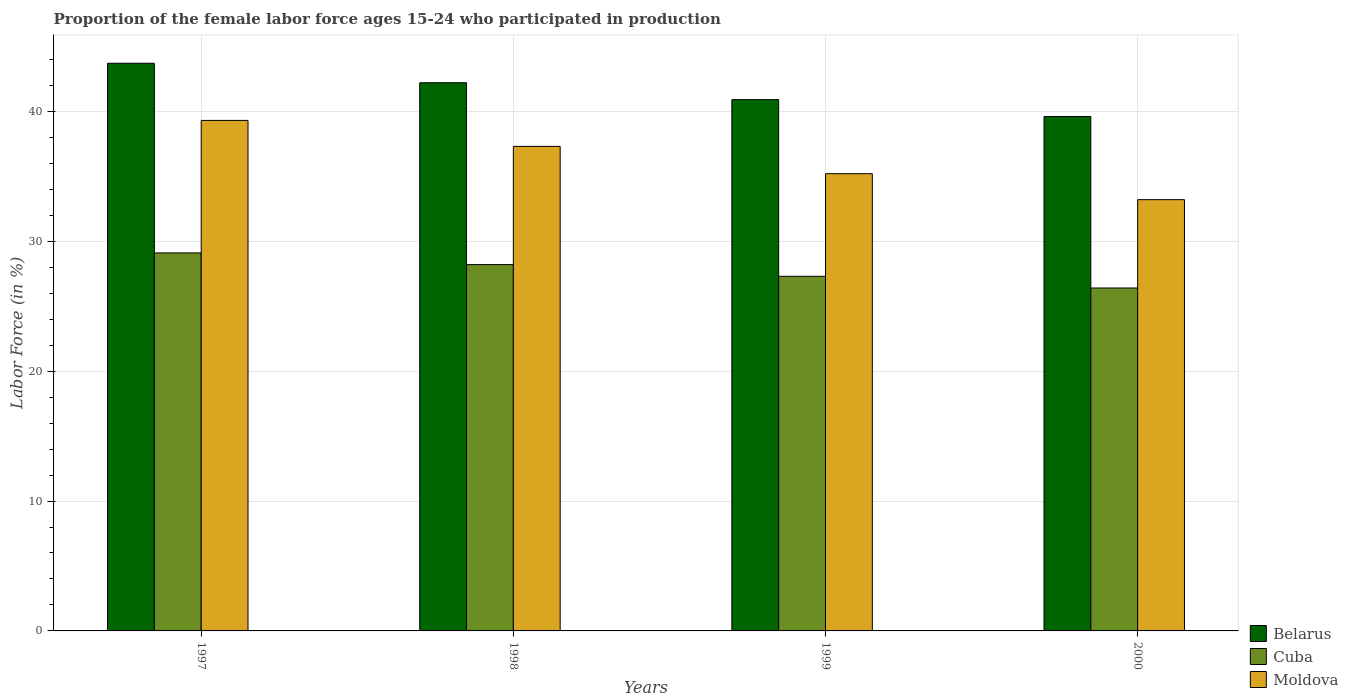How many groups of bars are there?
Provide a succinct answer. 4. What is the proportion of the female labor force who participated in production in Moldova in 1997?
Offer a very short reply. 39.3. Across all years, what is the maximum proportion of the female labor force who participated in production in Cuba?
Your answer should be compact. 29.1. Across all years, what is the minimum proportion of the female labor force who participated in production in Cuba?
Offer a terse response. 26.4. In which year was the proportion of the female labor force who participated in production in Belarus maximum?
Offer a terse response. 1997. In which year was the proportion of the female labor force who participated in production in Moldova minimum?
Keep it short and to the point. 2000. What is the total proportion of the female labor force who participated in production in Cuba in the graph?
Keep it short and to the point. 111. What is the difference between the proportion of the female labor force who participated in production in Cuba in 1999 and that in 2000?
Your answer should be compact. 0.9. What is the difference between the proportion of the female labor force who participated in production in Belarus in 1998 and the proportion of the female labor force who participated in production in Cuba in 1999?
Make the answer very short. 14.9. What is the average proportion of the female labor force who participated in production in Belarus per year?
Provide a short and direct response. 41.6. In the year 1997, what is the difference between the proportion of the female labor force who participated in production in Moldova and proportion of the female labor force who participated in production in Cuba?
Provide a succinct answer. 10.2. What is the ratio of the proportion of the female labor force who participated in production in Belarus in 1997 to that in 2000?
Keep it short and to the point. 1.1. Is the proportion of the female labor force who participated in production in Moldova in 1999 less than that in 2000?
Give a very brief answer. No. Is the difference between the proportion of the female labor force who participated in production in Moldova in 1999 and 2000 greater than the difference between the proportion of the female labor force who participated in production in Cuba in 1999 and 2000?
Give a very brief answer. Yes. What is the difference between the highest and the second highest proportion of the female labor force who participated in production in Belarus?
Ensure brevity in your answer.  1.5. What is the difference between the highest and the lowest proportion of the female labor force who participated in production in Cuba?
Offer a terse response. 2.7. In how many years, is the proportion of the female labor force who participated in production in Cuba greater than the average proportion of the female labor force who participated in production in Cuba taken over all years?
Your answer should be compact. 2. What does the 1st bar from the left in 1999 represents?
Your response must be concise. Belarus. What does the 3rd bar from the right in 1998 represents?
Ensure brevity in your answer.  Belarus. How many bars are there?
Offer a terse response. 12. Are all the bars in the graph horizontal?
Offer a terse response. No. Are the values on the major ticks of Y-axis written in scientific E-notation?
Give a very brief answer. No. Where does the legend appear in the graph?
Make the answer very short. Bottom right. How many legend labels are there?
Keep it short and to the point. 3. What is the title of the graph?
Your answer should be compact. Proportion of the female labor force ages 15-24 who participated in production. What is the label or title of the X-axis?
Ensure brevity in your answer.  Years. What is the label or title of the Y-axis?
Provide a short and direct response. Labor Force (in %). What is the Labor Force (in %) in Belarus in 1997?
Provide a short and direct response. 43.7. What is the Labor Force (in %) of Cuba in 1997?
Offer a very short reply. 29.1. What is the Labor Force (in %) in Moldova in 1997?
Provide a succinct answer. 39.3. What is the Labor Force (in %) of Belarus in 1998?
Make the answer very short. 42.2. What is the Labor Force (in %) in Cuba in 1998?
Your answer should be very brief. 28.2. What is the Labor Force (in %) of Moldova in 1998?
Give a very brief answer. 37.3. What is the Labor Force (in %) of Belarus in 1999?
Offer a terse response. 40.9. What is the Labor Force (in %) in Cuba in 1999?
Ensure brevity in your answer.  27.3. What is the Labor Force (in %) in Moldova in 1999?
Offer a very short reply. 35.2. What is the Labor Force (in %) in Belarus in 2000?
Keep it short and to the point. 39.6. What is the Labor Force (in %) in Cuba in 2000?
Ensure brevity in your answer.  26.4. What is the Labor Force (in %) in Moldova in 2000?
Keep it short and to the point. 33.2. Across all years, what is the maximum Labor Force (in %) of Belarus?
Your answer should be very brief. 43.7. Across all years, what is the maximum Labor Force (in %) of Cuba?
Keep it short and to the point. 29.1. Across all years, what is the maximum Labor Force (in %) of Moldova?
Provide a short and direct response. 39.3. Across all years, what is the minimum Labor Force (in %) of Belarus?
Make the answer very short. 39.6. Across all years, what is the minimum Labor Force (in %) in Cuba?
Provide a short and direct response. 26.4. Across all years, what is the minimum Labor Force (in %) in Moldova?
Your answer should be very brief. 33.2. What is the total Labor Force (in %) of Belarus in the graph?
Make the answer very short. 166.4. What is the total Labor Force (in %) of Cuba in the graph?
Your answer should be compact. 111. What is the total Labor Force (in %) of Moldova in the graph?
Offer a terse response. 145. What is the difference between the Labor Force (in %) in Belarus in 1997 and that in 1998?
Provide a short and direct response. 1.5. What is the difference between the Labor Force (in %) in Cuba in 1997 and that in 1998?
Keep it short and to the point. 0.9. What is the difference between the Labor Force (in %) in Moldova in 1997 and that in 1998?
Ensure brevity in your answer.  2. What is the difference between the Labor Force (in %) of Belarus in 1997 and that in 2000?
Offer a very short reply. 4.1. What is the difference between the Labor Force (in %) of Cuba in 1997 and that in 2000?
Offer a very short reply. 2.7. What is the difference between the Labor Force (in %) of Belarus in 1998 and that in 1999?
Offer a very short reply. 1.3. What is the difference between the Labor Force (in %) of Moldova in 1998 and that in 2000?
Your answer should be very brief. 4.1. What is the difference between the Labor Force (in %) of Belarus in 1999 and that in 2000?
Offer a very short reply. 1.3. What is the difference between the Labor Force (in %) in Belarus in 1997 and the Labor Force (in %) in Cuba in 1998?
Offer a very short reply. 15.5. What is the difference between the Labor Force (in %) in Belarus in 1997 and the Labor Force (in %) in Cuba in 1999?
Provide a succinct answer. 16.4. What is the difference between the Labor Force (in %) in Belarus in 1997 and the Labor Force (in %) in Moldova in 2000?
Offer a terse response. 10.5. What is the difference between the Labor Force (in %) of Cuba in 1997 and the Labor Force (in %) of Moldova in 2000?
Offer a very short reply. -4.1. What is the difference between the Labor Force (in %) of Cuba in 1998 and the Labor Force (in %) of Moldova in 2000?
Your answer should be very brief. -5. What is the average Labor Force (in %) of Belarus per year?
Your answer should be very brief. 41.6. What is the average Labor Force (in %) in Cuba per year?
Give a very brief answer. 27.75. What is the average Labor Force (in %) in Moldova per year?
Your answer should be compact. 36.25. In the year 1997, what is the difference between the Labor Force (in %) of Cuba and Labor Force (in %) of Moldova?
Your answer should be very brief. -10.2. In the year 1998, what is the difference between the Labor Force (in %) in Cuba and Labor Force (in %) in Moldova?
Ensure brevity in your answer.  -9.1. In the year 1999, what is the difference between the Labor Force (in %) of Belarus and Labor Force (in %) of Cuba?
Offer a terse response. 13.6. In the year 2000, what is the difference between the Labor Force (in %) in Belarus and Labor Force (in %) in Cuba?
Provide a succinct answer. 13.2. What is the ratio of the Labor Force (in %) of Belarus in 1997 to that in 1998?
Provide a short and direct response. 1.04. What is the ratio of the Labor Force (in %) in Cuba in 1997 to that in 1998?
Provide a succinct answer. 1.03. What is the ratio of the Labor Force (in %) in Moldova in 1997 to that in 1998?
Offer a terse response. 1.05. What is the ratio of the Labor Force (in %) in Belarus in 1997 to that in 1999?
Ensure brevity in your answer.  1.07. What is the ratio of the Labor Force (in %) of Cuba in 1997 to that in 1999?
Offer a terse response. 1.07. What is the ratio of the Labor Force (in %) of Moldova in 1997 to that in 1999?
Offer a terse response. 1.12. What is the ratio of the Labor Force (in %) in Belarus in 1997 to that in 2000?
Make the answer very short. 1.1. What is the ratio of the Labor Force (in %) in Cuba in 1997 to that in 2000?
Make the answer very short. 1.1. What is the ratio of the Labor Force (in %) in Moldova in 1997 to that in 2000?
Your answer should be very brief. 1.18. What is the ratio of the Labor Force (in %) in Belarus in 1998 to that in 1999?
Your response must be concise. 1.03. What is the ratio of the Labor Force (in %) in Cuba in 1998 to that in 1999?
Provide a succinct answer. 1.03. What is the ratio of the Labor Force (in %) in Moldova in 1998 to that in 1999?
Your response must be concise. 1.06. What is the ratio of the Labor Force (in %) in Belarus in 1998 to that in 2000?
Give a very brief answer. 1.07. What is the ratio of the Labor Force (in %) of Cuba in 1998 to that in 2000?
Make the answer very short. 1.07. What is the ratio of the Labor Force (in %) in Moldova in 1998 to that in 2000?
Make the answer very short. 1.12. What is the ratio of the Labor Force (in %) in Belarus in 1999 to that in 2000?
Make the answer very short. 1.03. What is the ratio of the Labor Force (in %) in Cuba in 1999 to that in 2000?
Your response must be concise. 1.03. What is the ratio of the Labor Force (in %) in Moldova in 1999 to that in 2000?
Offer a very short reply. 1.06. What is the difference between the highest and the second highest Labor Force (in %) of Belarus?
Your answer should be compact. 1.5. What is the difference between the highest and the lowest Labor Force (in %) in Cuba?
Make the answer very short. 2.7. What is the difference between the highest and the lowest Labor Force (in %) in Moldova?
Give a very brief answer. 6.1. 